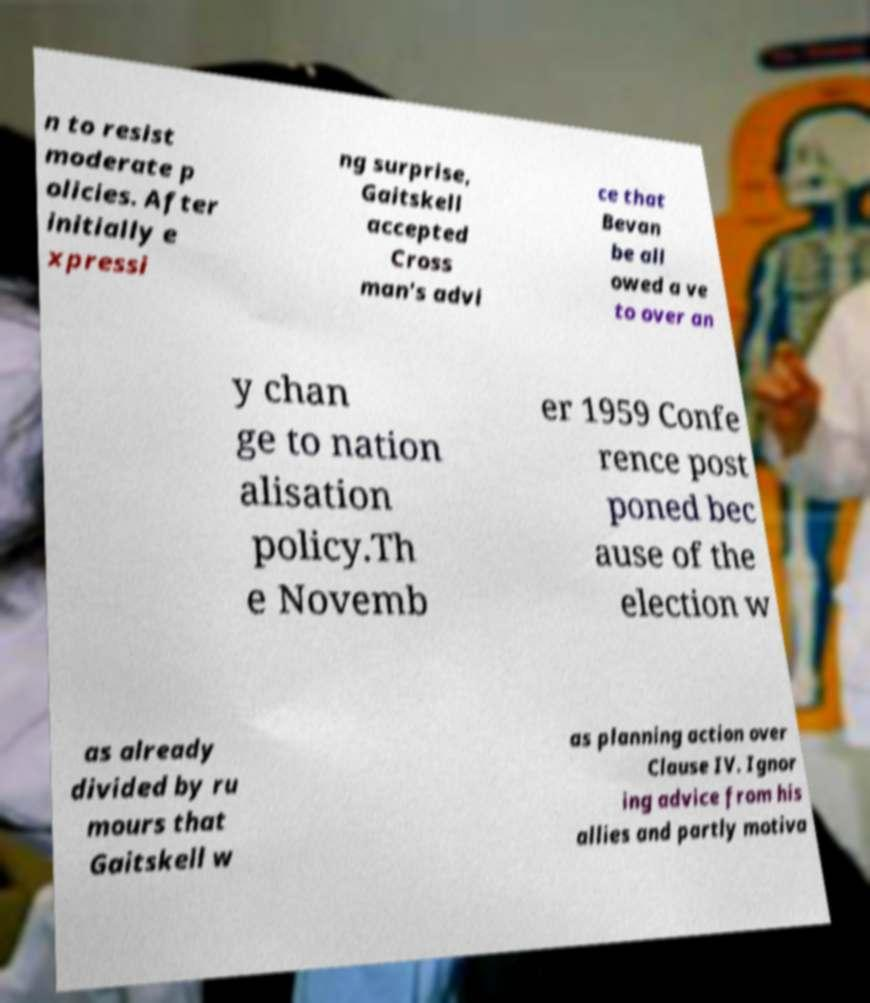Please read and relay the text visible in this image. What does it say? n to resist moderate p olicies. After initially e xpressi ng surprise, Gaitskell accepted Cross man's advi ce that Bevan be all owed a ve to over an y chan ge to nation alisation policy.Th e Novemb er 1959 Confe rence post poned bec ause of the election w as already divided by ru mours that Gaitskell w as planning action over Clause IV. Ignor ing advice from his allies and partly motiva 